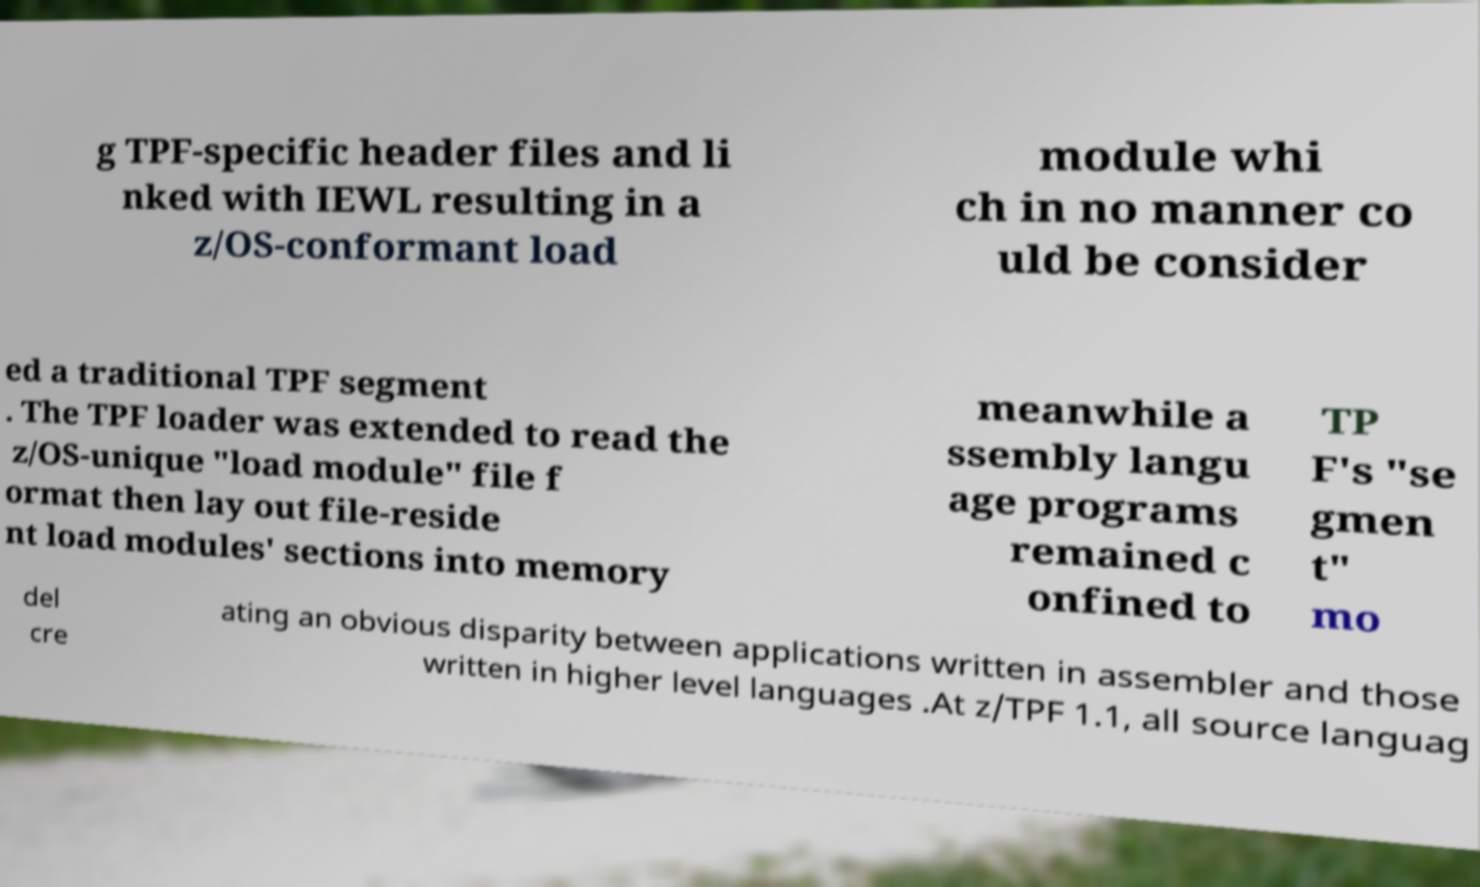Could you assist in decoding the text presented in this image and type it out clearly? g TPF-specific header files and li nked with IEWL resulting in a z/OS-conformant load module whi ch in no manner co uld be consider ed a traditional TPF segment . The TPF loader was extended to read the z/OS-unique "load module" file f ormat then lay out file-reside nt load modules' sections into memory meanwhile a ssembly langu age programs remained c onfined to TP F's "se gmen t" mo del cre ating an obvious disparity between applications written in assembler and those written in higher level languages .At z/TPF 1.1, all source languag 